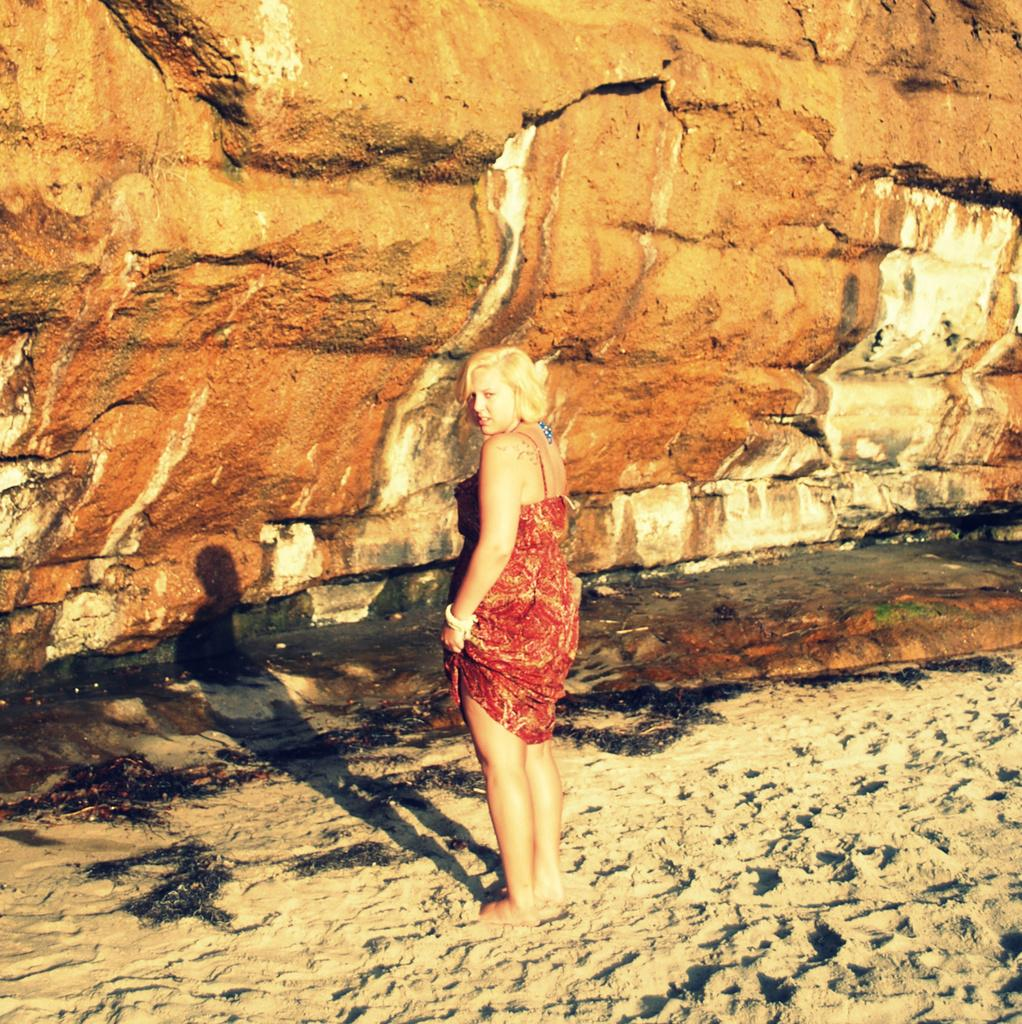Who is the main subject in the image? There is a woman in the image. What is the woman standing on? The woman is standing on the sand. What can be seen in the background behind the woman? There are rocks visible behind the woman. Can you see the woman's son playing with dirt in the image? There is no son or dirt present in the image. 